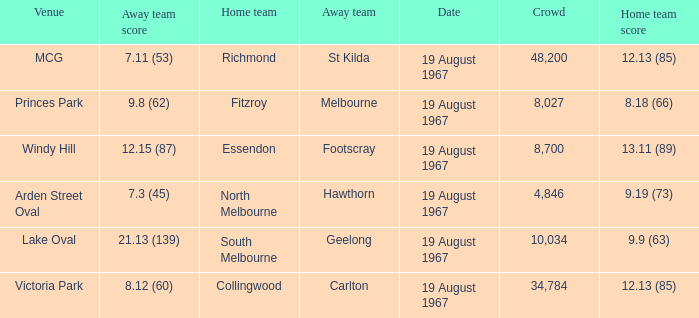When the venue was lake oval what did the home team score? 9.9 (63). 